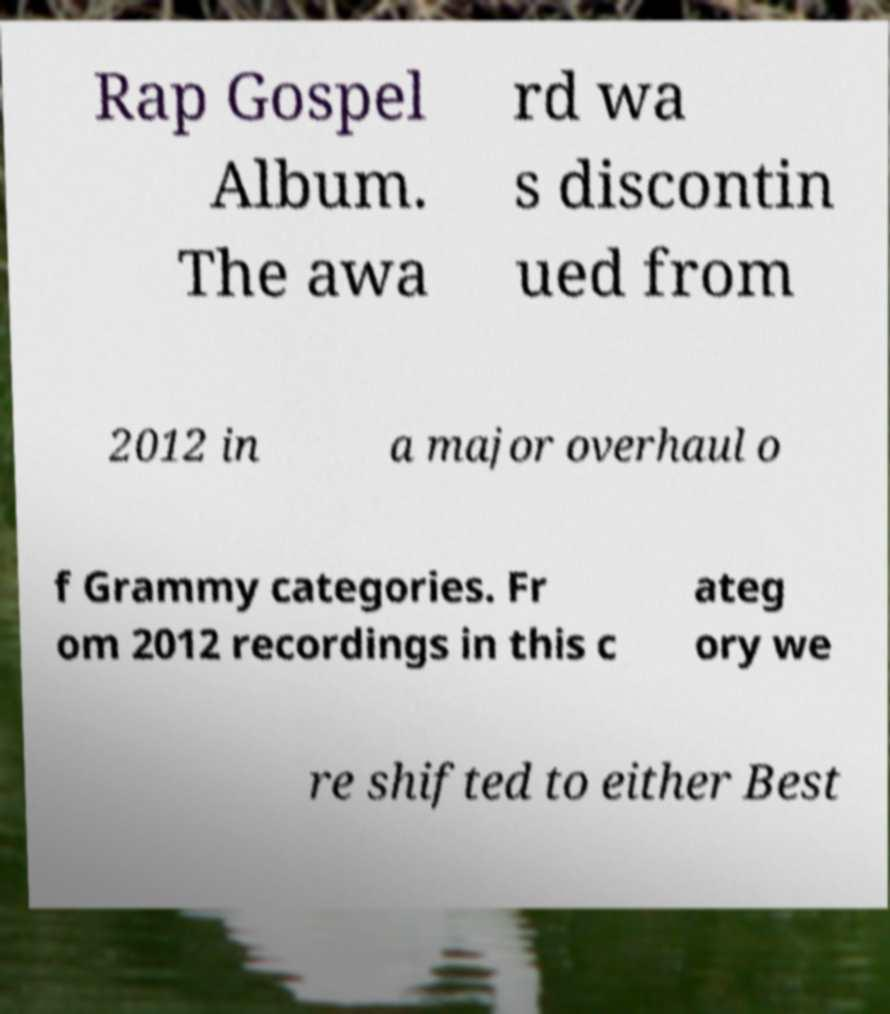For documentation purposes, I need the text within this image transcribed. Could you provide that? Rap Gospel Album. The awa rd wa s discontin ued from 2012 in a major overhaul o f Grammy categories. Fr om 2012 recordings in this c ateg ory we re shifted to either Best 